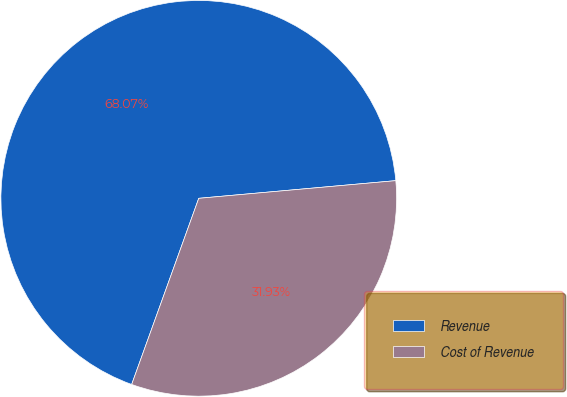Convert chart to OTSL. <chart><loc_0><loc_0><loc_500><loc_500><pie_chart><fcel>Revenue<fcel>Cost of Revenue<nl><fcel>68.07%<fcel>31.93%<nl></chart> 